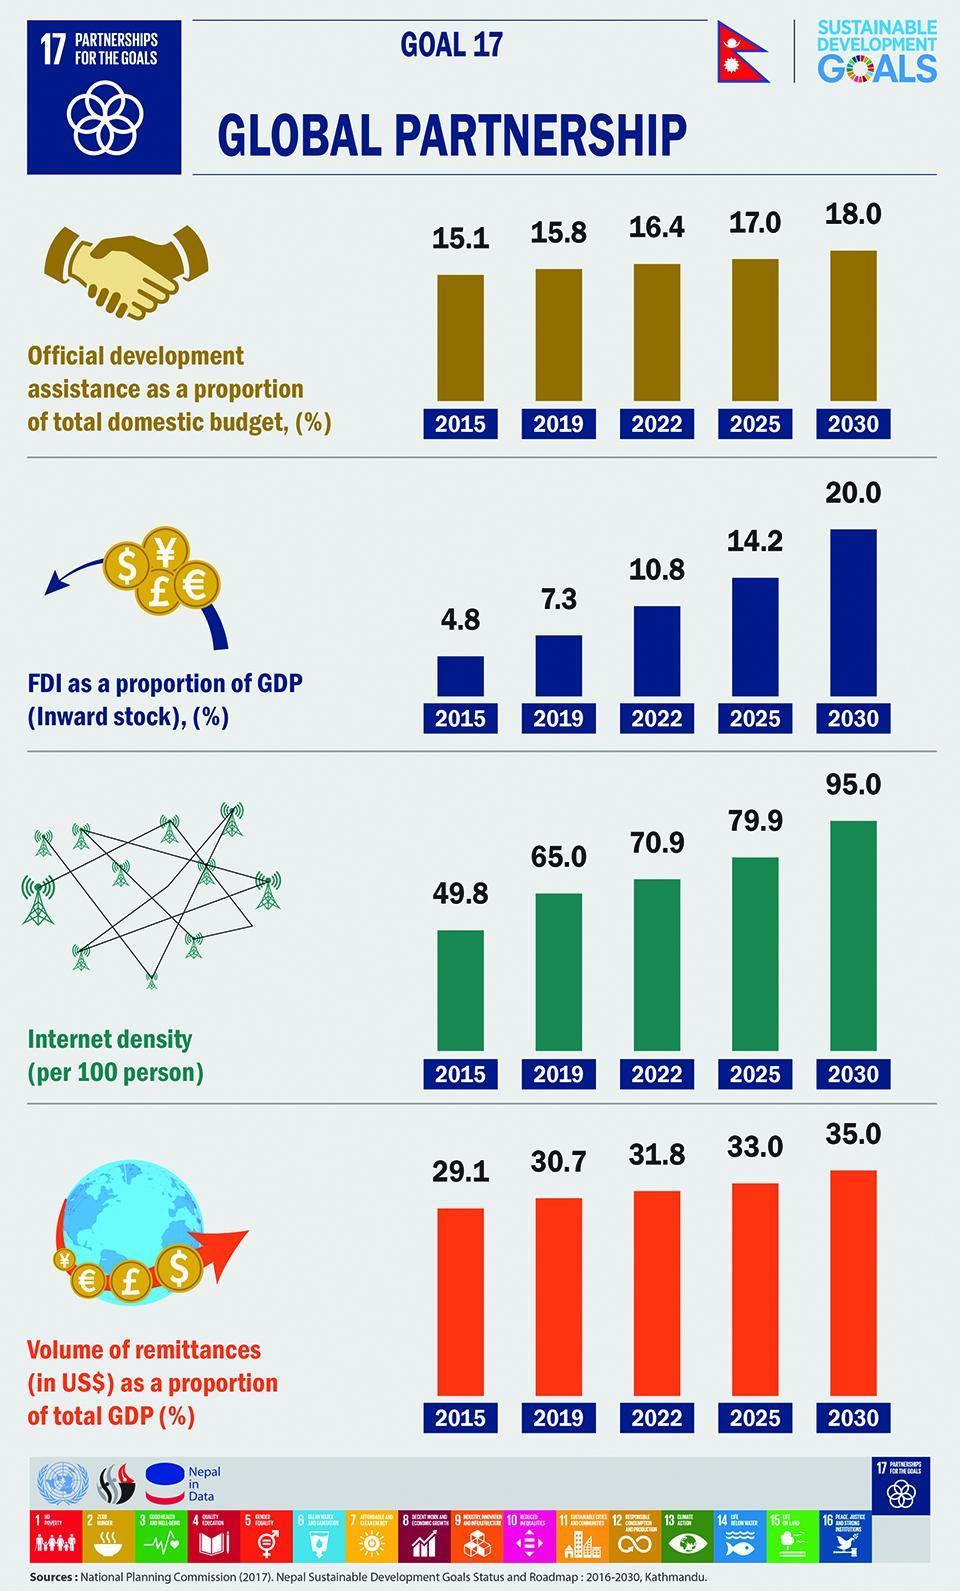What is the volume of remittances in 2022 and 2025, taken together?
Answer the question with a short phrase. 64.8 What is the FDI in 2022 and 2025, taken together? 25 What is the FDI in 2015 and 2019, taken together? 12.1 What is the internet density in 2022 and 2025, taken together? 150.8 What is the volume of remittances in 2015 and 2019, taken together? 59.8 What is the internet density in 2015 and 2019, taken together? 114.8 